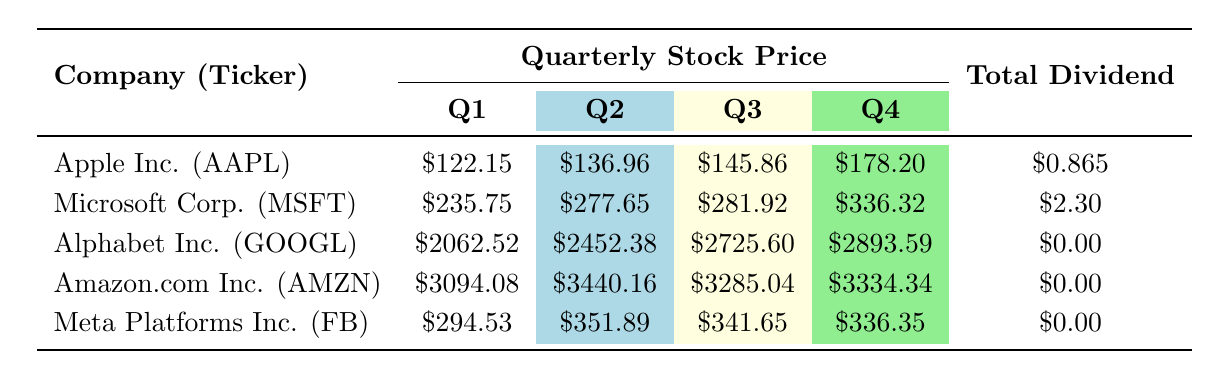What was the end stock price of Apple Inc. in Q4? The table shows the stock price end for each quarter, and for Apple Inc. (AAPL) in Q4, the value is directly listed as \$178.20.
Answer: 178.20 What was the total dividend received from Microsoft Corp. during 2021? The total dividend for Microsoft Corp. (MSFT) is summed up from the quarterly dividends listed in the table. It shows dividends of \$0.56 in Q1, Q2, and Q3, and \$0.62 in Q4. Adding these together gives \$0.56 + \$0.56 + \$0.56 + \$0.62 = \$2.30.
Answer: 2.30 Did Alphabet Inc. pay any dividends in 2021? Looking through the table, all quarters for Alphabet Inc. (GOOGL) show a dividend of \$0.00, indicating that no dividends were paid throughout the year.
Answer: Yes What was the highest stock price end of Amazon.com Inc. during 2021? The stock price ends for Amazon.com Inc. (AMZN) in each quarter are listed, and the values are \$3094.08 in Q1, \$3440.16 in Q2, \$3285.04 in Q3, and \$3334.34 in Q4. The highest value among these is \$3440.16 in Q2.
Answer: 3440.16 What is the average stock price end for Meta Platforms Inc. during 2021? To find the average stock price end for Meta Platforms Inc. (FB), we take the stock price end for each quarter: \$294.53 (Q1), \$351.89 (Q2), \$341.65 (Q3), and \$336.35 (Q4). We sum these values: \$294.53 + \$351.89 + \$341.65 + \$336.35 = \$1324.42 and then divide by 4, which gives us \$1324.42 / 4 = \$331.11.
Answer: 331.11 Which company had the lowest stock price at the end of Q1? In the table, the stock price end for Q1 shows \$122.15 for Apple Inc. (AAPL), \$235.75 for Microsoft Corp. (MSFT), \$2062.52 for Alphabet Inc. (GOOGL), \$3094.08 for Amazon.com Inc. (AMZN), and \$294.53 for Meta Platforms Inc. (FB). Among these, the lowest stock price at the end of Q1 is \$122.15 for Apple Inc.
Answer: Apple Inc 